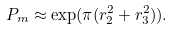Convert formula to latex. <formula><loc_0><loc_0><loc_500><loc_500>P _ { m } \approx \exp ( \pi ( r ^ { 2 } _ { 2 } + r ^ { 2 } _ { 3 } ) ) .</formula> 